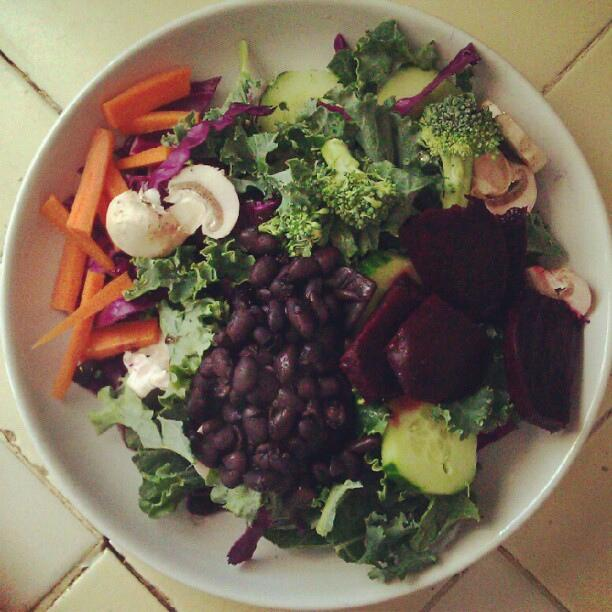What are the sliced red vegetables on the right side of dish called?

Choices:
A) red cabbage
B) eggplant
C) beets
D) radish beets 